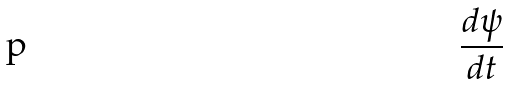Convert formula to latex. <formula><loc_0><loc_0><loc_500><loc_500>\frac { d \psi } { d t }</formula> 